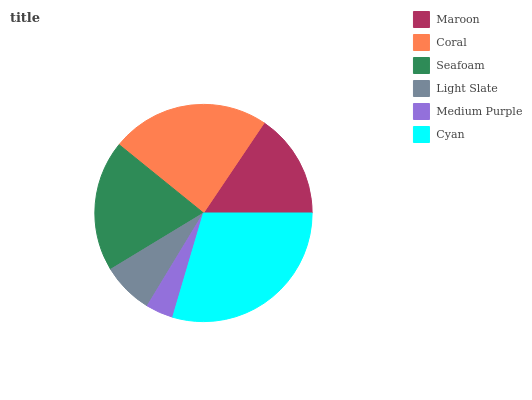Is Medium Purple the minimum?
Answer yes or no. Yes. Is Cyan the maximum?
Answer yes or no. Yes. Is Coral the minimum?
Answer yes or no. No. Is Coral the maximum?
Answer yes or no. No. Is Coral greater than Maroon?
Answer yes or no. Yes. Is Maroon less than Coral?
Answer yes or no. Yes. Is Maroon greater than Coral?
Answer yes or no. No. Is Coral less than Maroon?
Answer yes or no. No. Is Seafoam the high median?
Answer yes or no. Yes. Is Maroon the low median?
Answer yes or no. Yes. Is Maroon the high median?
Answer yes or no. No. Is Cyan the low median?
Answer yes or no. No. 